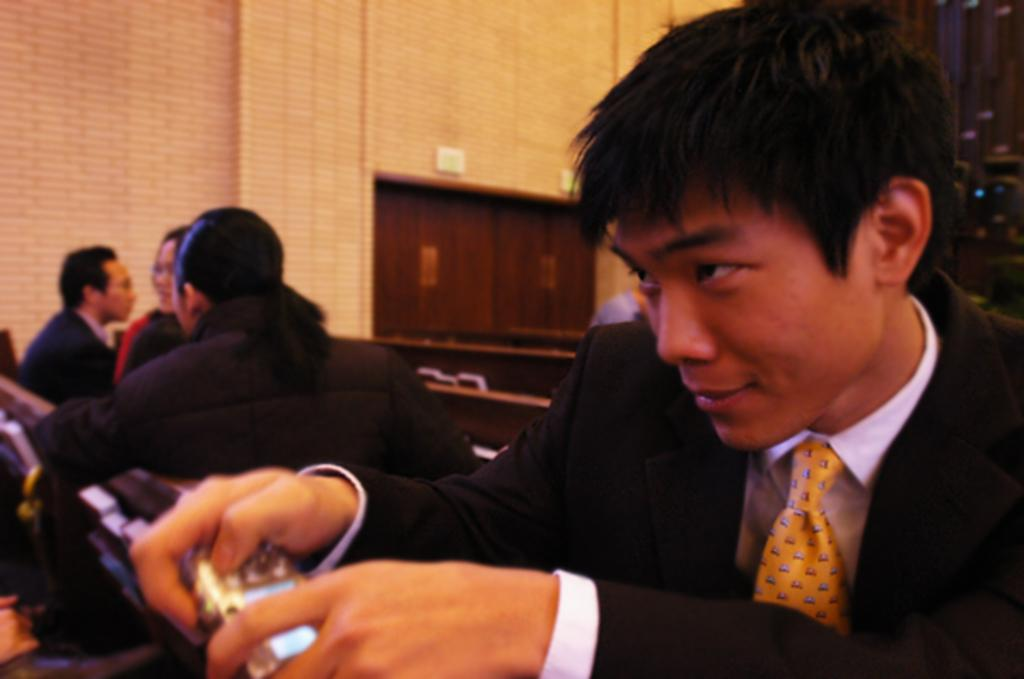What are the people in the image doing? There are groups of people sitting in the image. Can you describe the man in the black blazer? The man in the black blazer is present in the image and is holding an object. What can be seen in the background of the image? There is a wall with a door in the background of the image. How does the man in the black blazer sort the objects in the image? There is no indication in the image that the man in the black blazer is sorting any objects. 